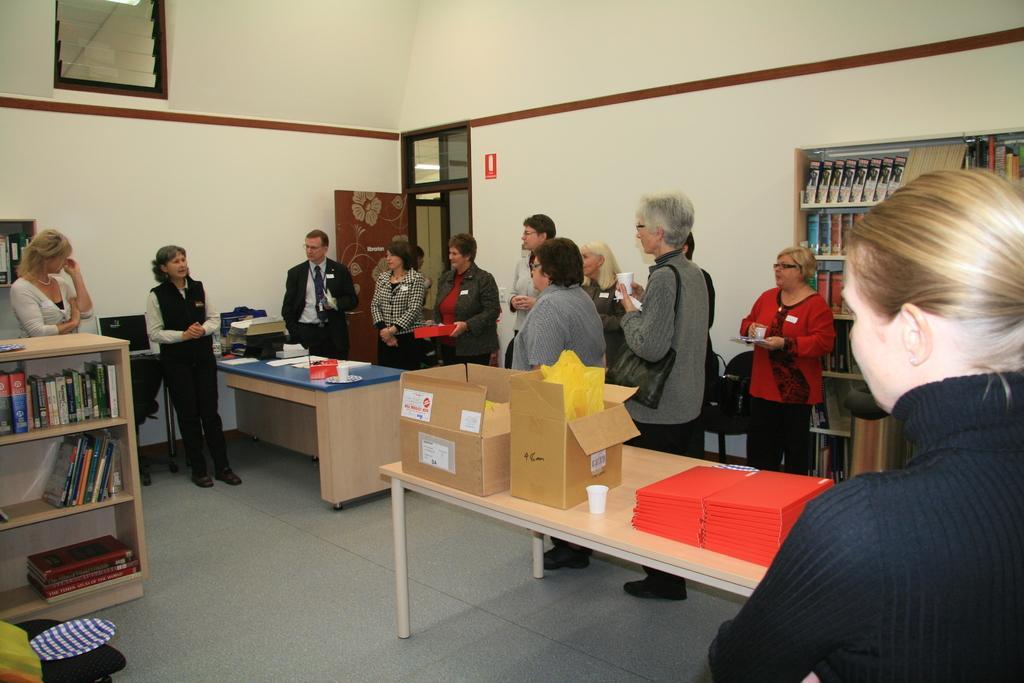Can you describe this image briefly? In this image there are group of people standing,the women standing here is talking,there are few books in a wooden rack. There are two art boards, a glass,few books on a table. At the background there is a wall and a door. 